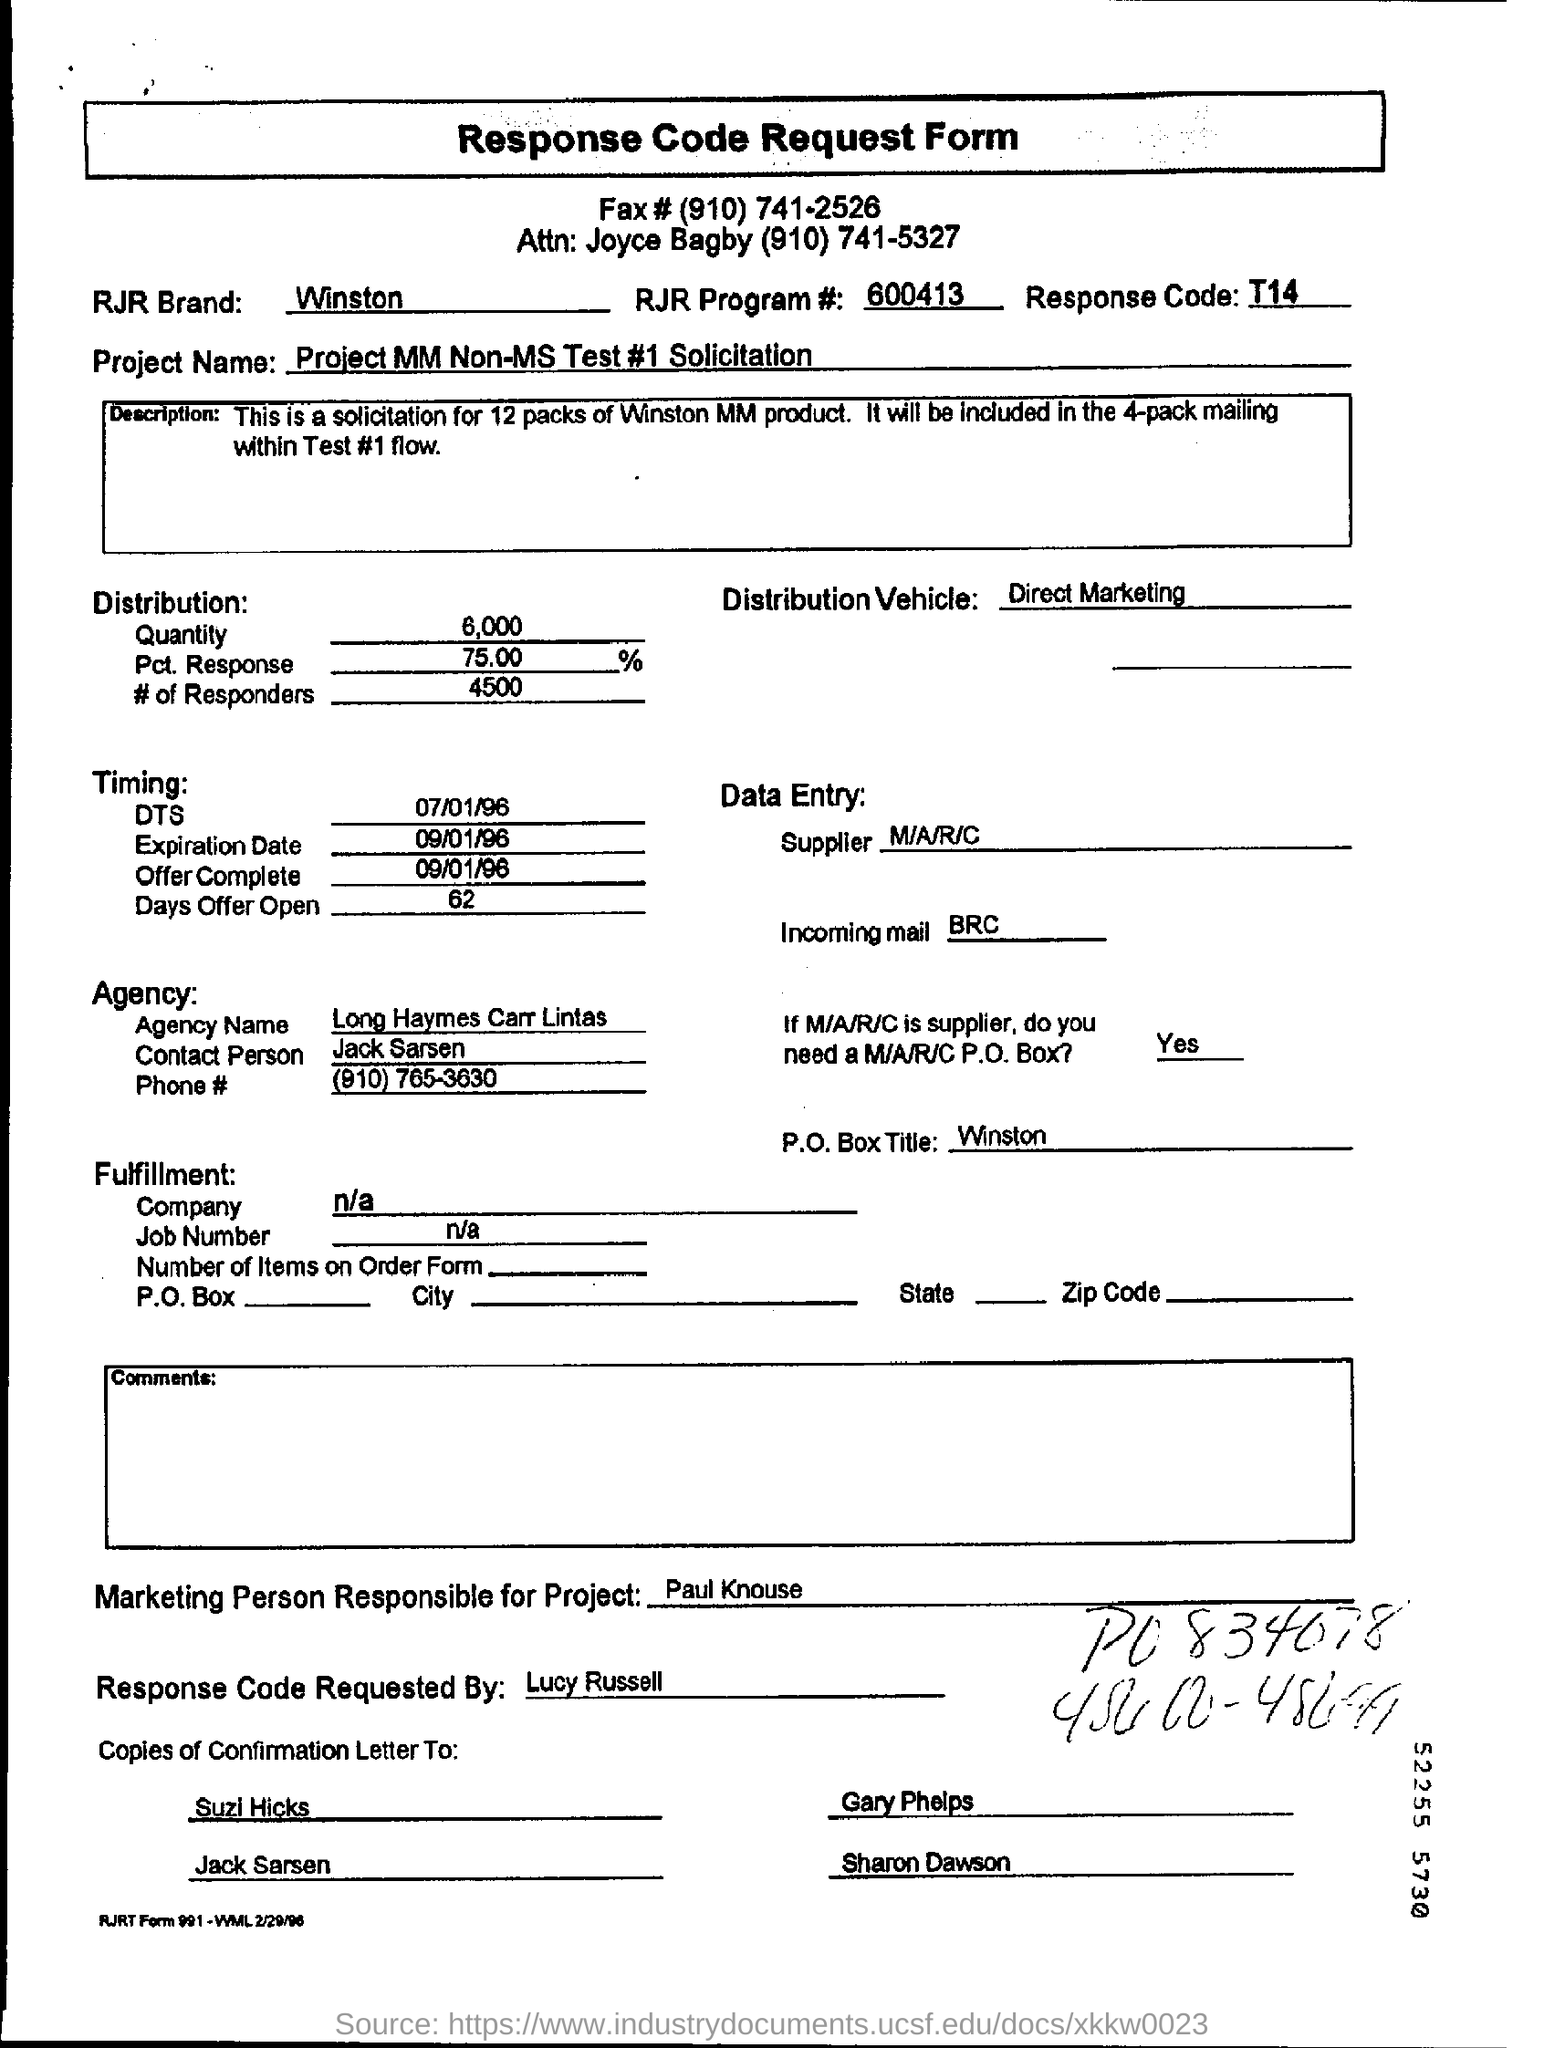Indicate a few pertinent items in this graphic. The P.O.Box title is [P.O.Box title], Winston. Jack Sarsen will be the contact person for the agency. 